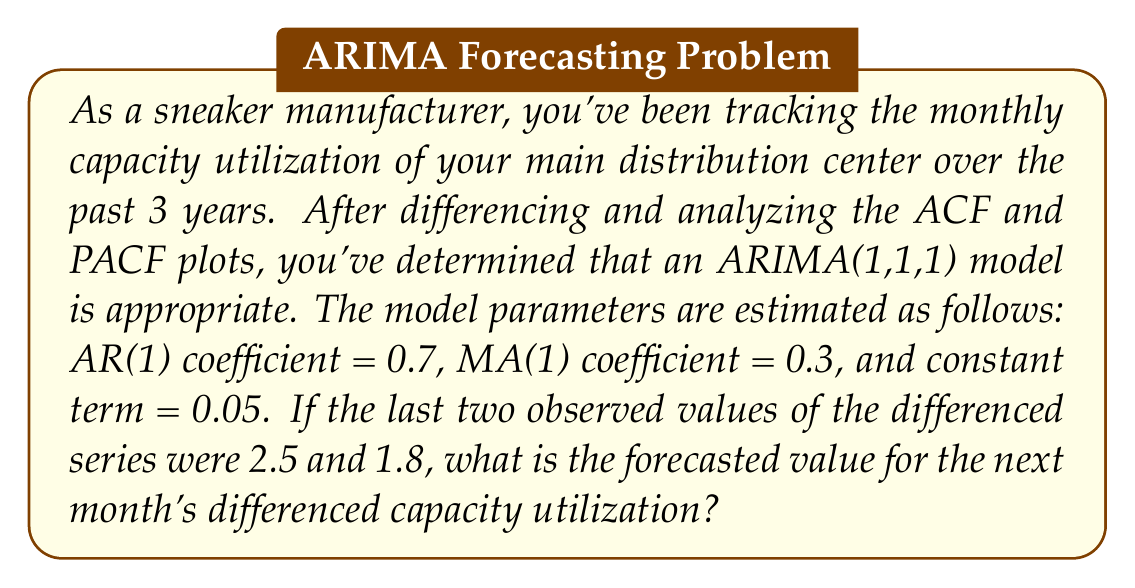Can you answer this question? To solve this problem, we'll use the ARIMA(1,1,1) model equation and the given information. Let's break it down step-by-step:

1) The general form of an ARIMA(1,1,1) model for the differenced series $y_t$ is:

   $$(1 - \phi_1B)(1-B)Y_t = c + (1 + \theta_1B)\varepsilon_t$$

   where $B$ is the backshift operator, $\phi_1$ is the AR(1) coefficient, $\theta_1$ is the MA(1) coefficient, $c$ is the constant term, and $\varepsilon_t$ is the error term.

2) Expanding this equation:

   $$y_t - \phi_1y_{t-1} = c + \varepsilon_t + \theta_1\varepsilon_{t-1}$$

3) Given:
   - $\phi_1 = 0.7$ (AR(1) coefficient)
   - $\theta_1 = 0.3$ (MA(1) coefficient)
   - $c = 0.05$ (constant term)
   - $y_{t-1} = 2.5$ (last observed differenced value)
   - $y_{t-2} = 1.8$ (second-to-last observed differenced value)

4) To forecast $y_t$, we need to estimate $\varepsilon_{t-1}$. We can do this using the previous equation:

   $$\varepsilon_{t-1} = y_{t-1} - \phi_1y_{t-2} - c$$
   $$\varepsilon_{t-1} = 2.5 - 0.7(1.8) - 0.05 = 1.19$$

5) Now we can forecast $y_t$. We assume $\varepsilon_t = 0$ for forecasting:

   $$y_t = \phi_1y_{t-1} + c + \theta_1\varepsilon_{t-1}$$
   $$y_t = 0.7(2.5) + 0.05 + 0.3(1.19)$$
   $$y_t = 1.75 + 0.05 + 0.357$$
   $$y_t = 2.157$$

Therefore, the forecasted value for the next month's differenced capacity utilization is approximately 2.157.
Answer: 2.157 